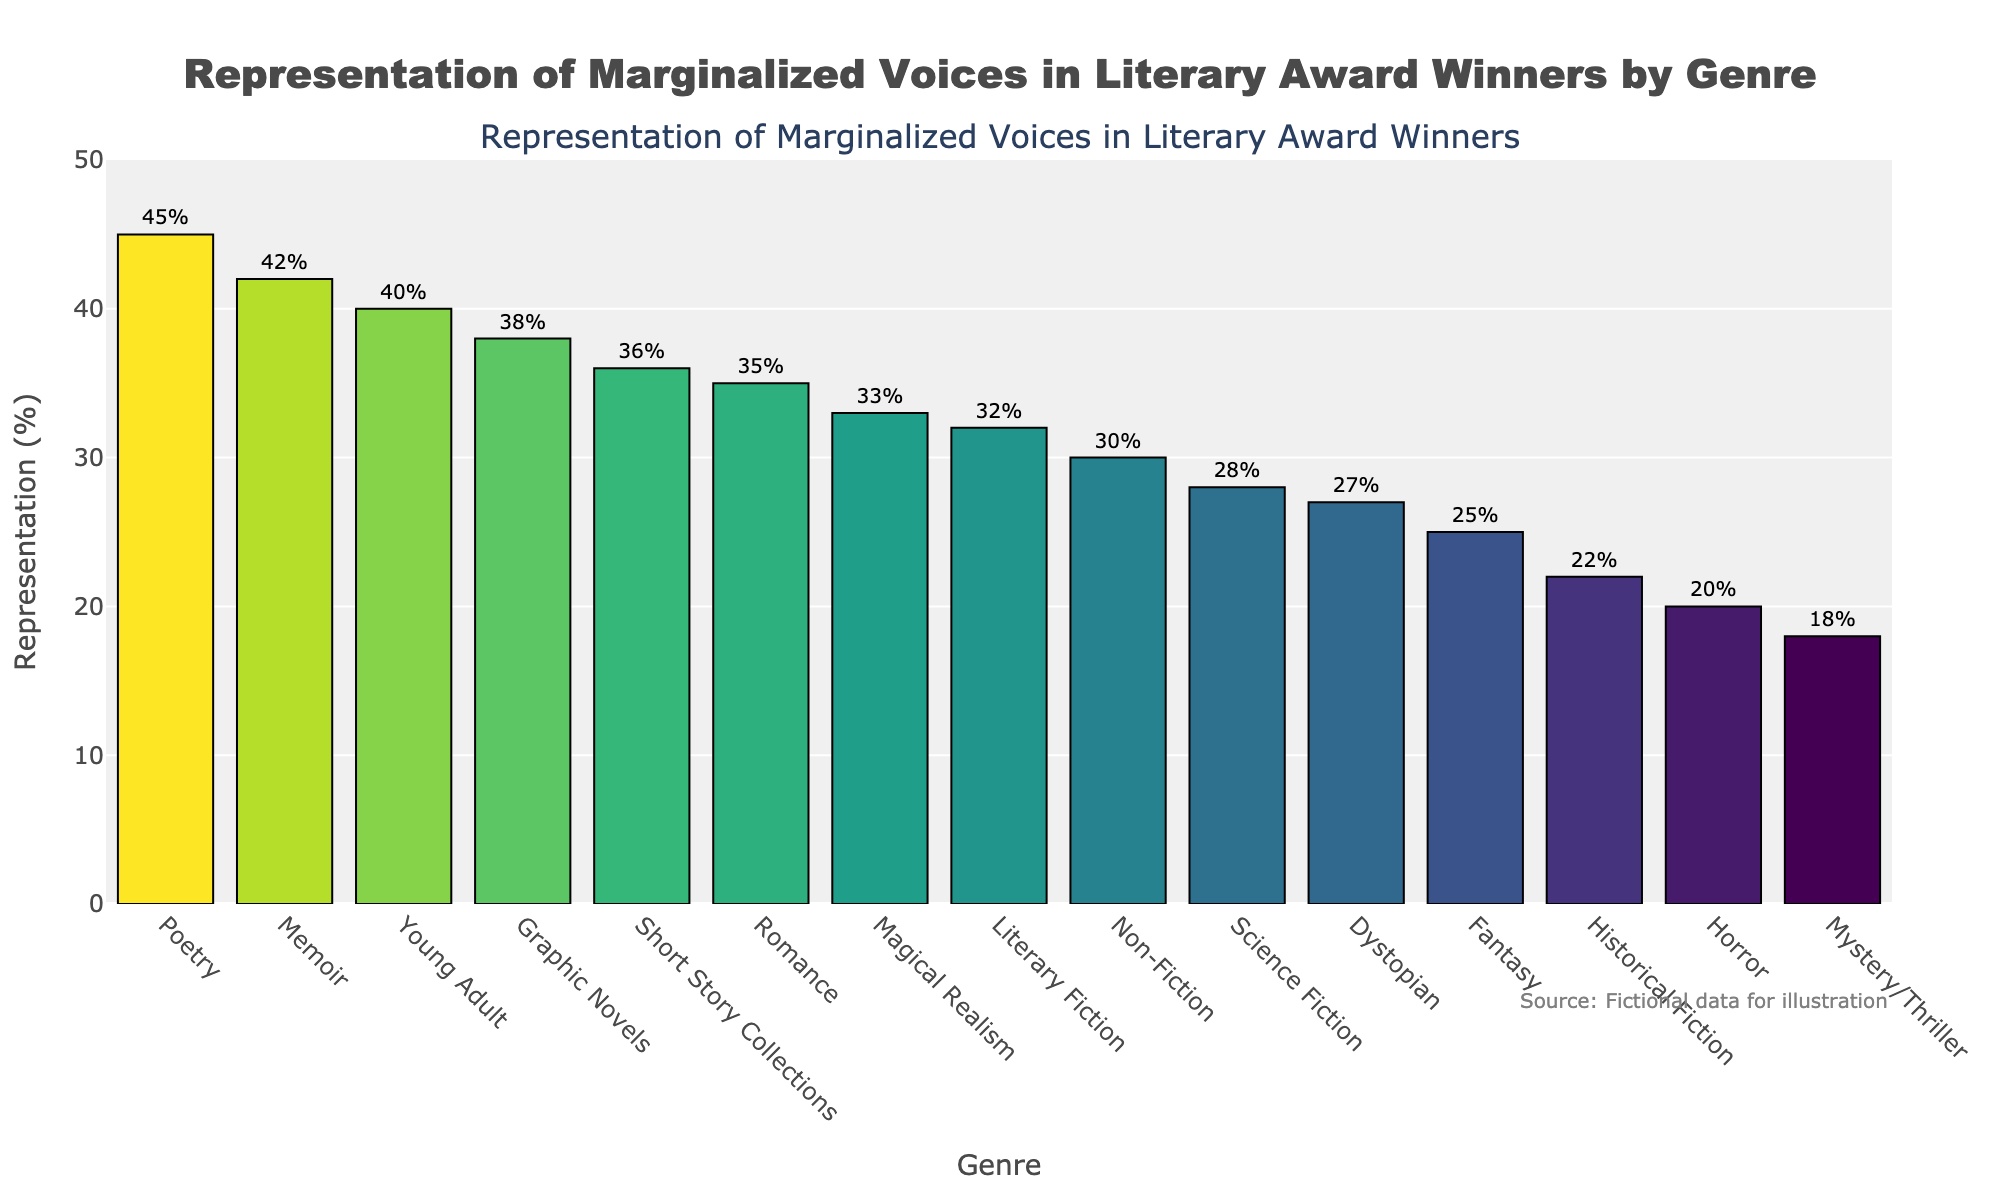What genre has the highest representation of marginalized voices? The genre with the highest representation of marginalized voices in the plot can be identified by looking for the tallest bar. For example, Poetry has the highest representation with 45%.
Answer: Poetry Which genre has a lower representation of marginalized voices: Historical Fiction or Memoir? To determine which genre has a lower representation, compare the heights of the bars for Historical Fiction and Memoir. Historical Fiction is at 22% and Memoir is at 42%.
Answer: Historical Fiction What is the average representation percentage of marginalized voices for Science Fiction, Fantasy, and Horror? To calculate the average representation percentage, sum the percentages for Science Fiction (28%), Fantasy (25%), and Horror (20%), then divide by 3. The sum is 28 + 25 + 20 = 73, and the average is 73 / 3 = 24.33%.
Answer: 24.33% Which genre has the median value of representation percentage of marginalized voices? To find the median value, list all the percentages in ascending order and identify the middle value. Ordered values are 18, 20, 22, 25, 27, 28, 30, 32, 33, 35, 36, 38, 40, 42, 45. The middle value (8th in the list) is 32%, corresponding to Literary Fiction.
Answer: Literary Fiction Is Romance's representation percentage greater than that of Young Adult? Compare the heights of the bars for Romance (35%) and Young Adult (40%). Young Adult has a higher representation.
Answer: No What is the difference in representation percentage between the highest and lowest genres? The highest representation is Poetry at 45% and the lowest is Mystery/Thriller at 18%. The difference is 45 - 18 = 27%.
Answer: 27% How does the representation of marginalized voices in Non-Fiction compare to Short Story Collections? Compare the values: Non-Fiction has 30% and Short Story Collections have 36%. Short Story Collections have a higher representation.
Answer: Short Story Collections is higher If we group Sci-Fi, Fantasy, and Dystopian genres together, what is their combined representation percentage compared to the combined percentage of Memoir and Graphic Novels? Calculate the sum for Sci-Fi, Fantasy, and Dystopian (28% + 25% + 27% = 80%) and Memoir and Graphic Novels (42% + 38% = 80%). Both groups have an equal combined representation percentage.
Answer: 80% and 80% What is the range of representation percentages across all genres? The range is the difference between the highest (Poetry at 45%) and lowest (Mystery/Thriller at 18%) values: 45 - 18 = 27%.
Answer: 27% Which genres have representation percentages of marginalized voices greater than 30% but less than 40%? Identify bars within the 30% to 40% range: Literary Fiction (32%), Romance (35%), Non-Fiction (30%), Graphic Novels (38%), Magical Realism (33%), Short Story Collections (36%).
Answer: Literary Fiction, Romance, Non-Fiction, Graphic Novels, Magical Realism, Short Story Collections 